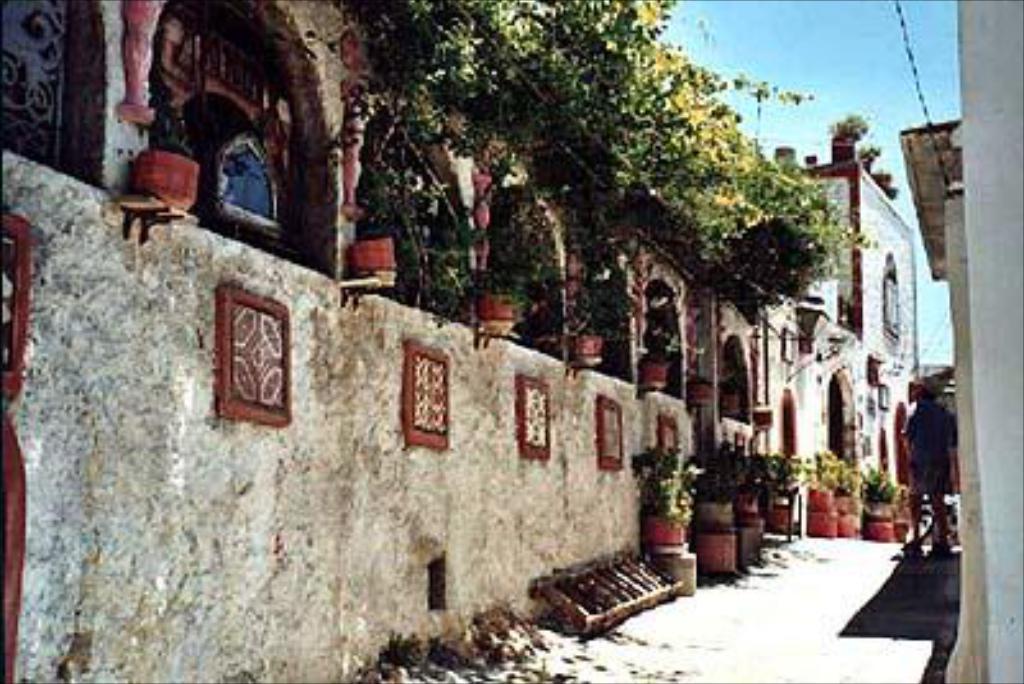How would you summarize this image in a sentence or two? In this picture we can see house plants, ladder, buildings, trees and some objects and a person standing on the ground and in the background we can see the sky. 